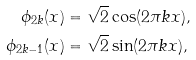Convert formula to latex. <formula><loc_0><loc_0><loc_500><loc_500>\phi _ { 2 k } ( x ) & = \sqrt { 2 } \cos ( 2 \pi k x ) , \\ \phi _ { 2 k - 1 } ( x ) & = \sqrt { 2 } \sin ( 2 \pi k x ) ,</formula> 